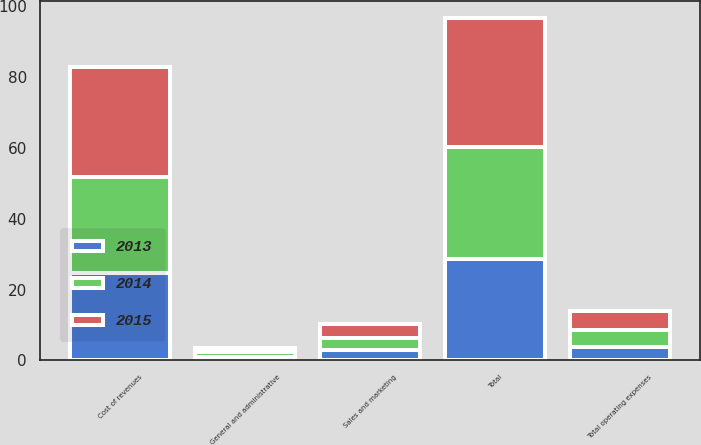Convert chart to OTSL. <chart><loc_0><loc_0><loc_500><loc_500><stacked_bar_chart><ecel><fcel>Cost of revenues<fcel>Sales and marketing<fcel>General and administrative<fcel>Total operating expenses<fcel>Total<nl><fcel>2013<fcel>24.6<fcel>2.8<fcel>1.1<fcel>3.9<fcel>28.5<nl><fcel>2015<fcel>30.9<fcel>4.2<fcel>1.2<fcel>5.4<fcel>36.3<nl><fcel>2014<fcel>27.3<fcel>3.4<fcel>1.2<fcel>4.6<fcel>31.9<nl></chart> 